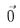Convert formula to latex. <formula><loc_0><loc_0><loc_500><loc_500>\vec { 0 }</formula> 